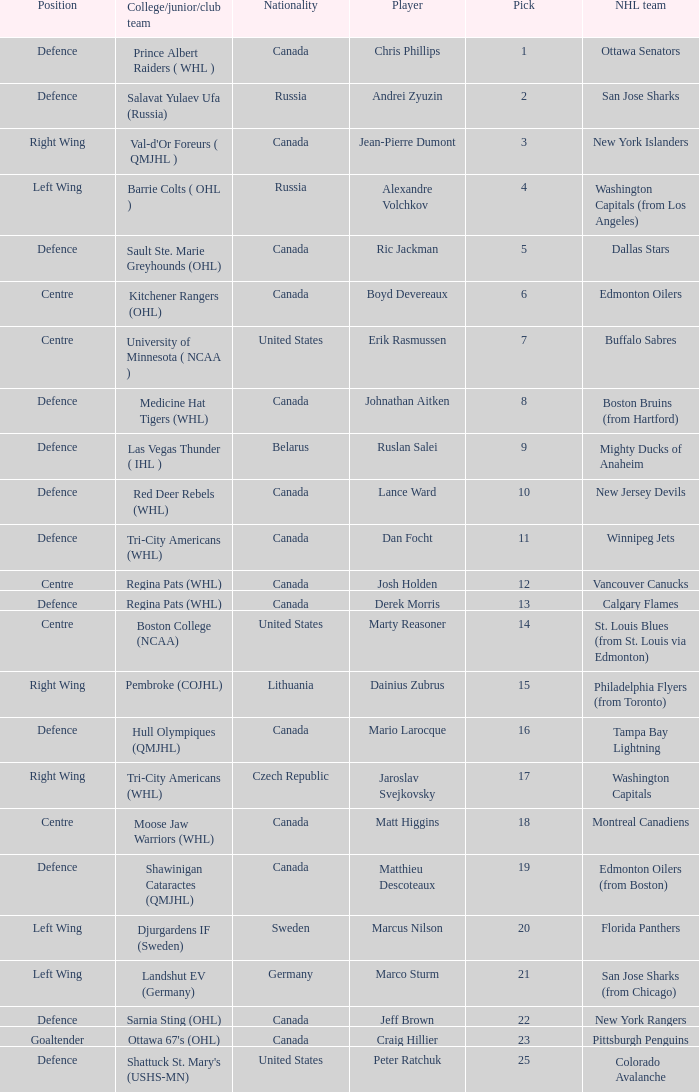I'm looking to parse the entire table for insights. Could you assist me with that? {'header': ['Position', 'College/junior/club team', 'Nationality', 'Player', 'Pick', 'NHL team'], 'rows': [['Defence', 'Prince Albert Raiders ( WHL )', 'Canada', 'Chris Phillips', '1', 'Ottawa Senators'], ['Defence', 'Salavat Yulaev Ufa (Russia)', 'Russia', 'Andrei Zyuzin', '2', 'San Jose Sharks'], ['Right Wing', "Val-d'Or Foreurs ( QMJHL )", 'Canada', 'Jean-Pierre Dumont', '3', 'New York Islanders'], ['Left Wing', 'Barrie Colts ( OHL )', 'Russia', 'Alexandre Volchkov', '4', 'Washington Capitals (from Los Angeles)'], ['Defence', 'Sault Ste. Marie Greyhounds (OHL)', 'Canada', 'Ric Jackman', '5', 'Dallas Stars'], ['Centre', 'Kitchener Rangers (OHL)', 'Canada', 'Boyd Devereaux', '6', 'Edmonton Oilers'], ['Centre', 'University of Minnesota ( NCAA )', 'United States', 'Erik Rasmussen', '7', 'Buffalo Sabres'], ['Defence', 'Medicine Hat Tigers (WHL)', 'Canada', 'Johnathan Aitken', '8', 'Boston Bruins (from Hartford)'], ['Defence', 'Las Vegas Thunder ( IHL )', 'Belarus', 'Ruslan Salei', '9', 'Mighty Ducks of Anaheim'], ['Defence', 'Red Deer Rebels (WHL)', 'Canada', 'Lance Ward', '10', 'New Jersey Devils'], ['Defence', 'Tri-City Americans (WHL)', 'Canada', 'Dan Focht', '11', 'Winnipeg Jets'], ['Centre', 'Regina Pats (WHL)', 'Canada', 'Josh Holden', '12', 'Vancouver Canucks'], ['Defence', 'Regina Pats (WHL)', 'Canada', 'Derek Morris', '13', 'Calgary Flames'], ['Centre', 'Boston College (NCAA)', 'United States', 'Marty Reasoner', '14', 'St. Louis Blues (from St. Louis via Edmonton)'], ['Right Wing', 'Pembroke (COJHL)', 'Lithuania', 'Dainius Zubrus', '15', 'Philadelphia Flyers (from Toronto)'], ['Defence', 'Hull Olympiques (QMJHL)', 'Canada', 'Mario Larocque', '16', 'Tampa Bay Lightning'], ['Right Wing', 'Tri-City Americans (WHL)', 'Czech Republic', 'Jaroslav Svejkovsky', '17', 'Washington Capitals'], ['Centre', 'Moose Jaw Warriors (WHL)', 'Canada', 'Matt Higgins', '18', 'Montreal Canadiens'], ['Defence', 'Shawinigan Cataractes (QMJHL)', 'Canada', 'Matthieu Descoteaux', '19', 'Edmonton Oilers (from Boston)'], ['Left Wing', 'Djurgardens IF (Sweden)', 'Sweden', 'Marcus Nilson', '20', 'Florida Panthers'], ['Left Wing', 'Landshut EV (Germany)', 'Germany', 'Marco Sturm', '21', 'San Jose Sharks (from Chicago)'], ['Defence', 'Sarnia Sting (OHL)', 'Canada', 'Jeff Brown', '22', 'New York Rangers'], ['Goaltender', "Ottawa 67's (OHL)", 'Canada', 'Craig Hillier', '23', 'Pittsburgh Penguins'], ['Defence', "Shattuck St. Mary's (USHS-MN)", 'United States', 'Peter Ratchuk', '25', 'Colorado Avalanche']]} How many positions does the draft pick whose nationality is Czech Republic play? 1.0. 